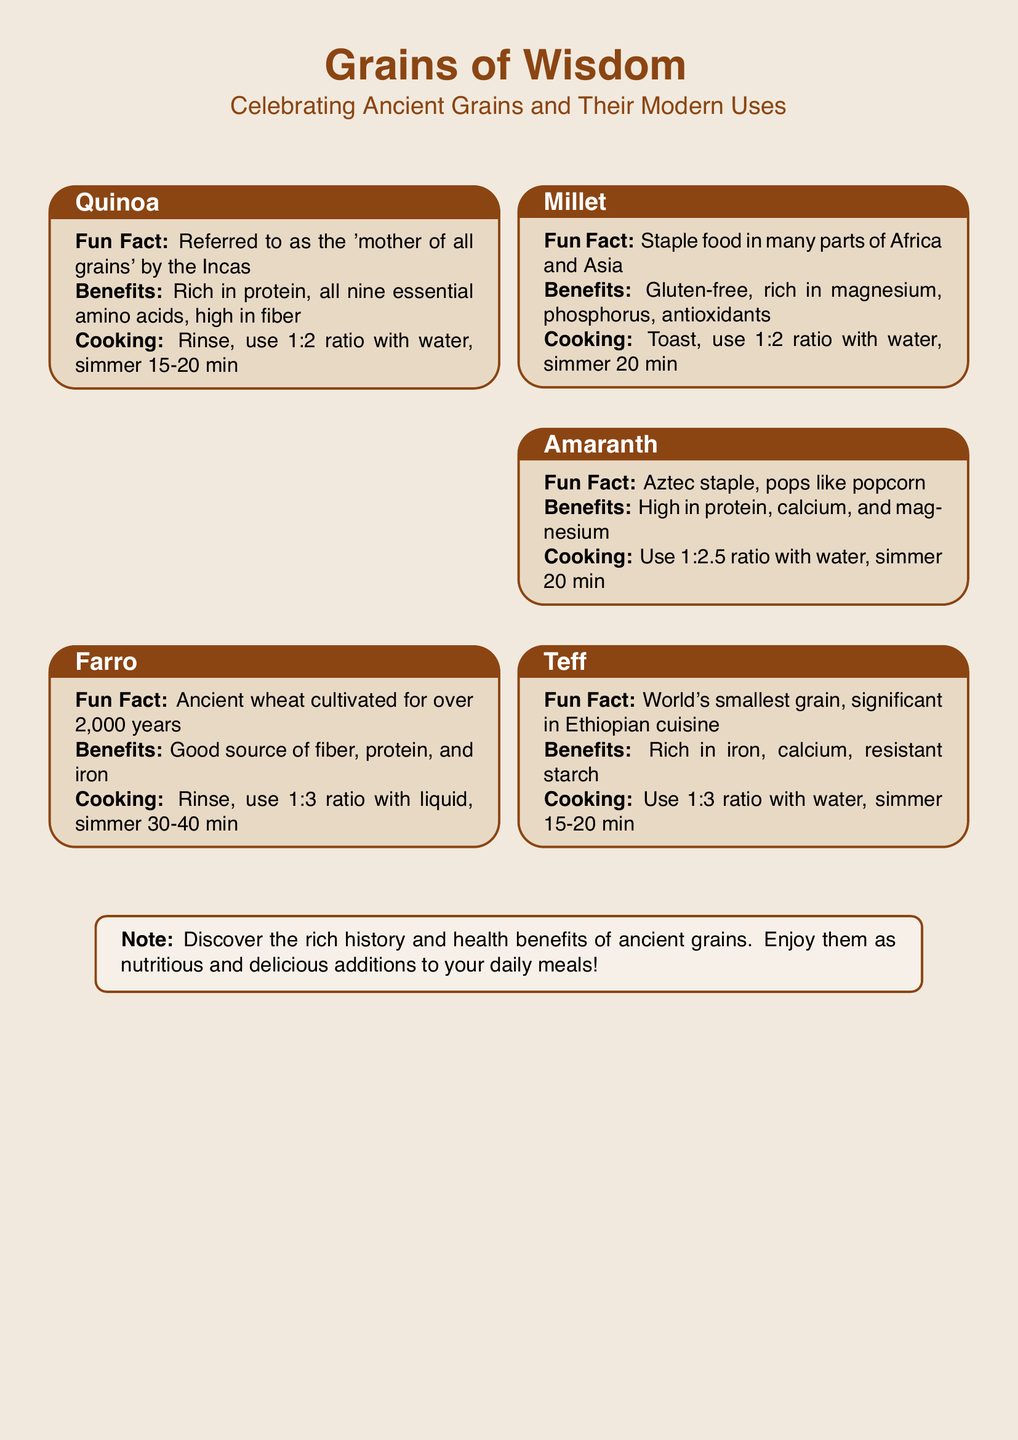What is the title of the document? The title is stated at the top of the card.
Answer: Grains of Wisdom How many ancient grains are featured on the card? The card lists five ancient grains.
Answer: Five What is the fun fact about Quinoa? The fun fact is specific to Quinoa and highlights its significance.
Answer: Referred to as the 'mother of all grains' by the Incas What benefits are associated with Farro? The benefits listed are specific to Farro.
Answer: Good source of fiber, protein, and iron How much water should be used to cook Amaranth? The ratio for cooking Amaranth is provided in the cooking instructions.
Answer: 1:2.5 ratio with water Which ancient grain is mentioned as having a significant role in Ethiopian cuisine? The specific grain linked to Ethiopian cuisine is noted in its description.
Answer: Teff What is the cooking time for Millet? The cooking time is included in the cooking instructions for Millet.
Answer: 20 min Which ancient grain is gluten-free? The document mentions a specific grain that is gluten-free.
Answer: Millet What is the color of the page background? The color of the page background is described in the document setup.
Answer: Light brown 